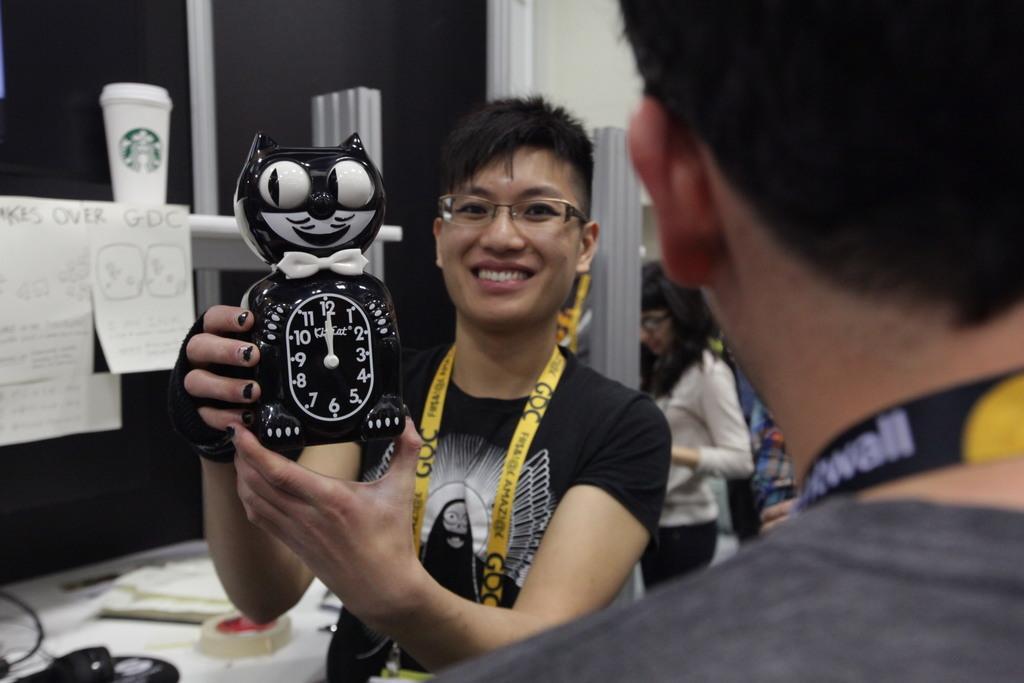Describe this image in one or two sentences. In the front of the image there are two people and wore tags. Among them one person wearing spectacles and holding a clock. In the background of the image there are papers, a cup, a woman, wall, table and things. Something is written on the papers and tags.   